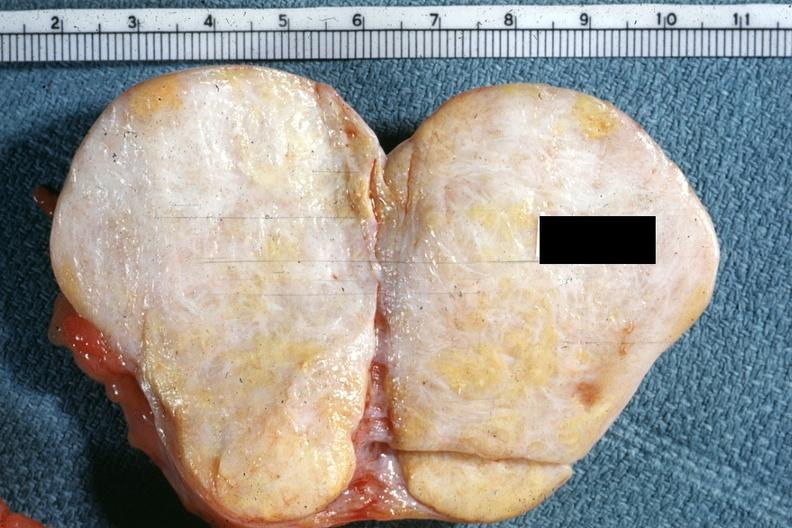where does this belong to?
Answer the question using a single word or phrase. Female reproductive system 